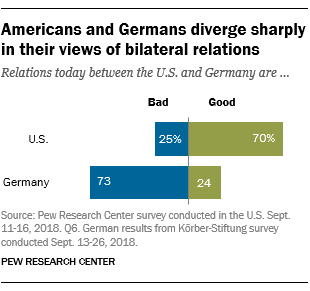Specify some key components in this picture. The average of the blue bar is greater than the average of the green bar. The percentage value of bad bars in the U.S. is 25%. 